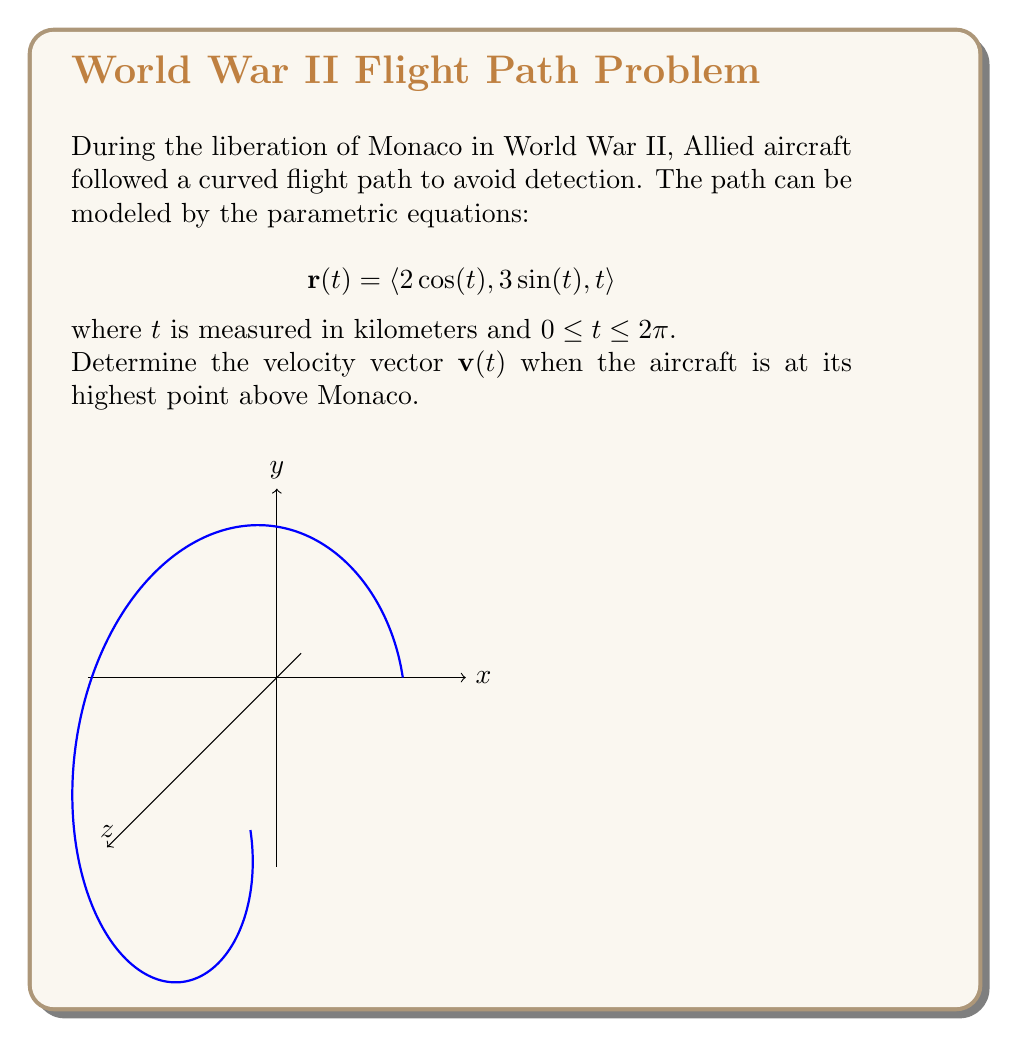Can you solve this math problem? Let's approach this step-by-step:

1) First, we need to find the velocity vector $\mathbf{v}(t)$. This is the derivative of the position vector $\mathbf{r}(t)$ with respect to $t$:

   $$\mathbf{v}(t) = \frac{d}{dt}\mathbf{r}(t) = \langle -2\sin(t), 3\cos(t), 1 \rangle$$

2) To find when the aircraft is at its highest point, we need to determine when the z-coordinate is maximum. The z-coordinate is simply $t$, which reaches its maximum when $t = 2\pi$ (the upper bound of the given range).

3) Now we can calculate the velocity vector at this point by substituting $t = 2\pi$ into our expression for $\mathbf{v}(t)$:

   $$\mathbf{v}(2\pi) = \langle -2\sin(2\pi), 3\cos(2\pi), 1 \rangle$$

4) Simplify:
   - $\sin(2\pi) = 0$
   - $\cos(2\pi) = 1$

   Therefore:
   $$\mathbf{v}(2\pi) = \langle 0, 3, 1 \rangle$$

This velocity vector indicates that at its highest point, the aircraft is moving parallel to the y-z plane, with a greater component in the y-direction than the z-direction.
Answer: $\langle 0, 3, 1 \rangle$ 